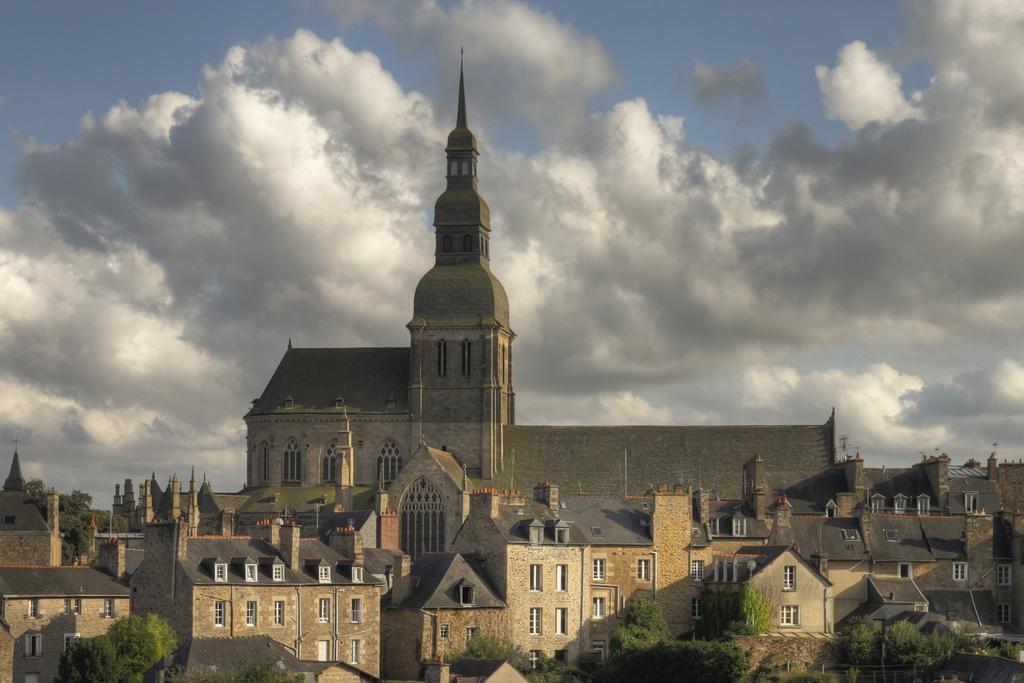How would you summarize this image in a sentence or two? In this image I can see houses, buildings, trees and the sky. This image is taken may be during a sunny day. 